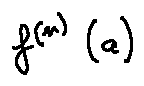Convert formula to latex. <formula><loc_0><loc_0><loc_500><loc_500>f ^ { ( n ) } ( a )</formula> 